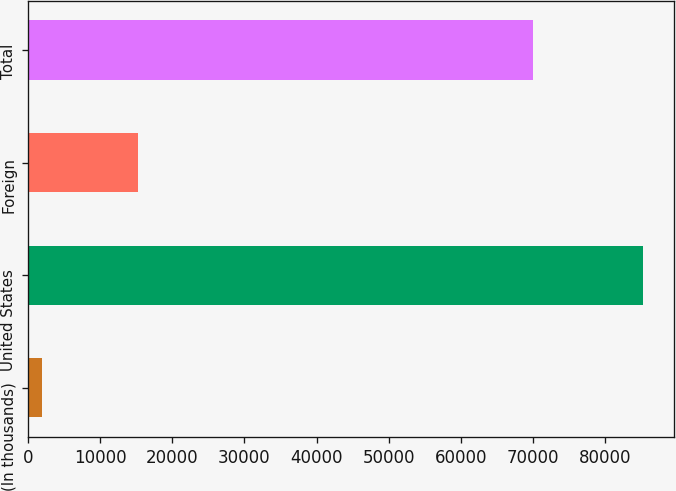Convert chart. <chart><loc_0><loc_0><loc_500><loc_500><bar_chart><fcel>(In thousands)<fcel>United States<fcel>Foreign<fcel>Total<nl><fcel>2008<fcel>85204<fcel>15304<fcel>69900<nl></chart> 